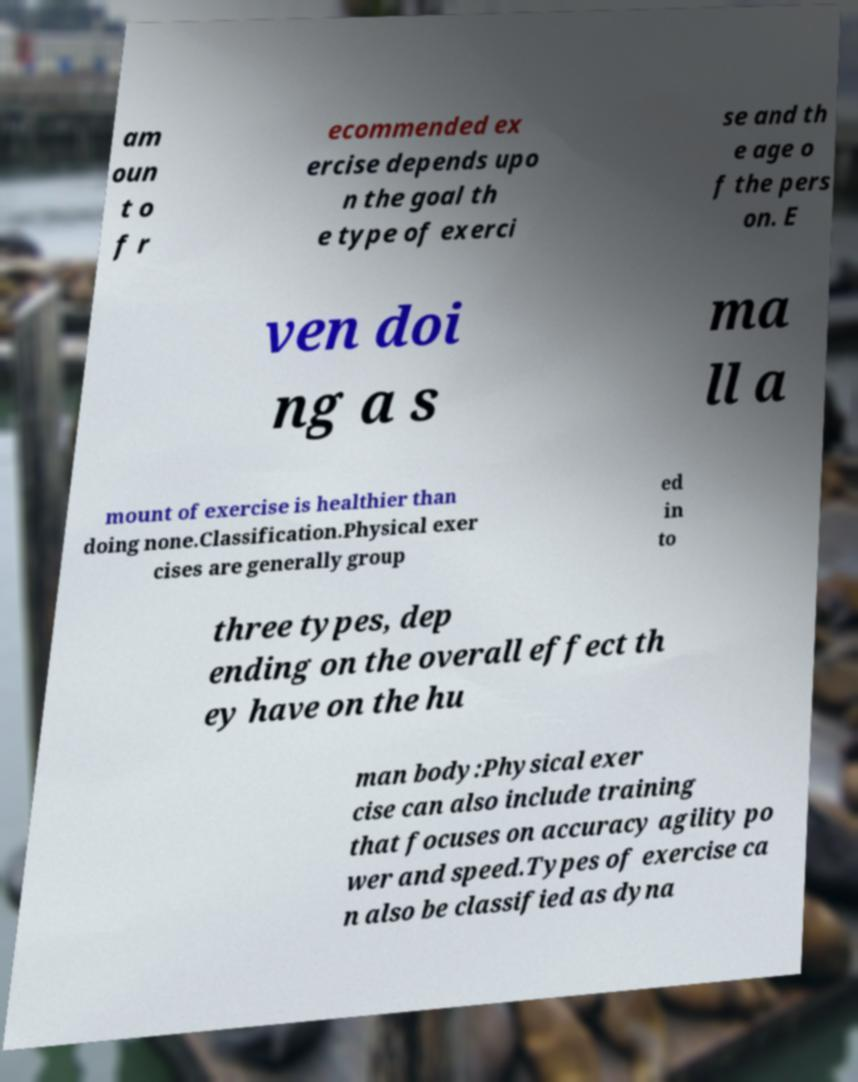I need the written content from this picture converted into text. Can you do that? am oun t o f r ecommended ex ercise depends upo n the goal th e type of exerci se and th e age o f the pers on. E ven doi ng a s ma ll a mount of exercise is healthier than doing none.Classification.Physical exer cises are generally group ed in to three types, dep ending on the overall effect th ey have on the hu man body:Physical exer cise can also include training that focuses on accuracy agility po wer and speed.Types of exercise ca n also be classified as dyna 